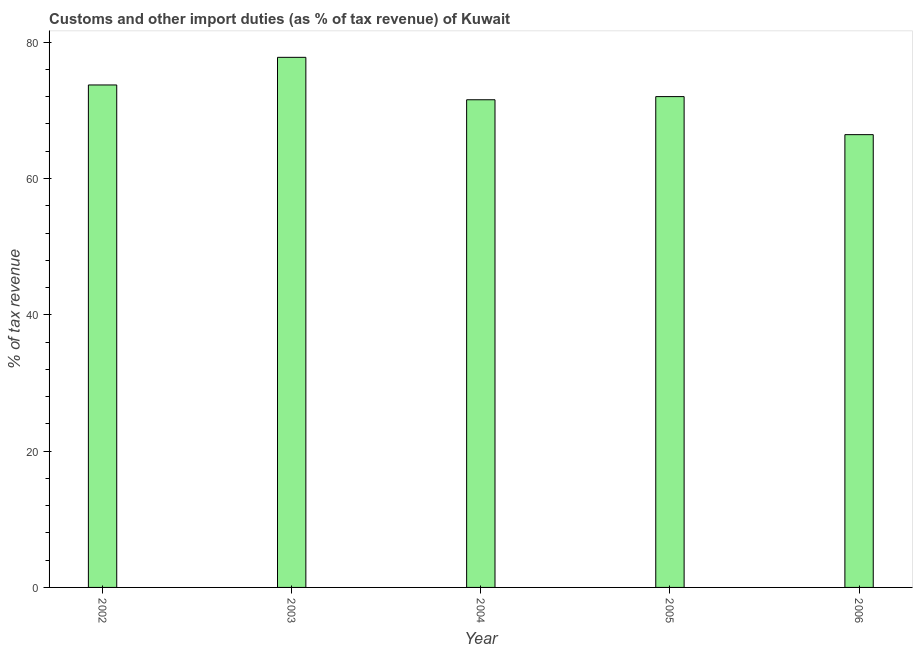Does the graph contain any zero values?
Offer a very short reply. No. What is the title of the graph?
Your answer should be very brief. Customs and other import duties (as % of tax revenue) of Kuwait. What is the label or title of the X-axis?
Your answer should be compact. Year. What is the label or title of the Y-axis?
Give a very brief answer. % of tax revenue. What is the customs and other import duties in 2003?
Your answer should be compact. 77.78. Across all years, what is the maximum customs and other import duties?
Make the answer very short. 77.78. Across all years, what is the minimum customs and other import duties?
Make the answer very short. 66.43. In which year was the customs and other import duties maximum?
Offer a terse response. 2003. In which year was the customs and other import duties minimum?
Provide a succinct answer. 2006. What is the sum of the customs and other import duties?
Your answer should be compact. 361.5. What is the difference between the customs and other import duties in 2003 and 2004?
Offer a very short reply. 6.23. What is the average customs and other import duties per year?
Make the answer very short. 72.3. What is the median customs and other import duties?
Your response must be concise. 72.02. In how many years, is the customs and other import duties greater than 60 %?
Keep it short and to the point. 5. Is the difference between the customs and other import duties in 2002 and 2003 greater than the difference between any two years?
Offer a terse response. No. What is the difference between the highest and the second highest customs and other import duties?
Your response must be concise. 4.05. Is the sum of the customs and other import duties in 2005 and 2006 greater than the maximum customs and other import duties across all years?
Provide a short and direct response. Yes. What is the difference between the highest and the lowest customs and other import duties?
Keep it short and to the point. 11.34. How many years are there in the graph?
Provide a short and direct response. 5. Are the values on the major ticks of Y-axis written in scientific E-notation?
Provide a short and direct response. No. What is the % of tax revenue of 2002?
Provide a short and direct response. 73.72. What is the % of tax revenue in 2003?
Give a very brief answer. 77.78. What is the % of tax revenue in 2004?
Your answer should be very brief. 71.55. What is the % of tax revenue in 2005?
Your response must be concise. 72.02. What is the % of tax revenue of 2006?
Your response must be concise. 66.43. What is the difference between the % of tax revenue in 2002 and 2003?
Offer a terse response. -4.06. What is the difference between the % of tax revenue in 2002 and 2004?
Ensure brevity in your answer.  2.17. What is the difference between the % of tax revenue in 2002 and 2005?
Provide a succinct answer. 1.71. What is the difference between the % of tax revenue in 2002 and 2006?
Offer a very short reply. 7.29. What is the difference between the % of tax revenue in 2003 and 2004?
Your answer should be compact. 6.23. What is the difference between the % of tax revenue in 2003 and 2005?
Ensure brevity in your answer.  5.76. What is the difference between the % of tax revenue in 2003 and 2006?
Your response must be concise. 11.34. What is the difference between the % of tax revenue in 2004 and 2005?
Your answer should be compact. -0.46. What is the difference between the % of tax revenue in 2004 and 2006?
Ensure brevity in your answer.  5.12. What is the difference between the % of tax revenue in 2005 and 2006?
Your answer should be very brief. 5.58. What is the ratio of the % of tax revenue in 2002 to that in 2003?
Your answer should be very brief. 0.95. What is the ratio of the % of tax revenue in 2002 to that in 2005?
Give a very brief answer. 1.02. What is the ratio of the % of tax revenue in 2002 to that in 2006?
Provide a succinct answer. 1.11. What is the ratio of the % of tax revenue in 2003 to that in 2004?
Give a very brief answer. 1.09. What is the ratio of the % of tax revenue in 2003 to that in 2005?
Your response must be concise. 1.08. What is the ratio of the % of tax revenue in 2003 to that in 2006?
Ensure brevity in your answer.  1.17. What is the ratio of the % of tax revenue in 2004 to that in 2006?
Your answer should be very brief. 1.08. What is the ratio of the % of tax revenue in 2005 to that in 2006?
Your answer should be very brief. 1.08. 